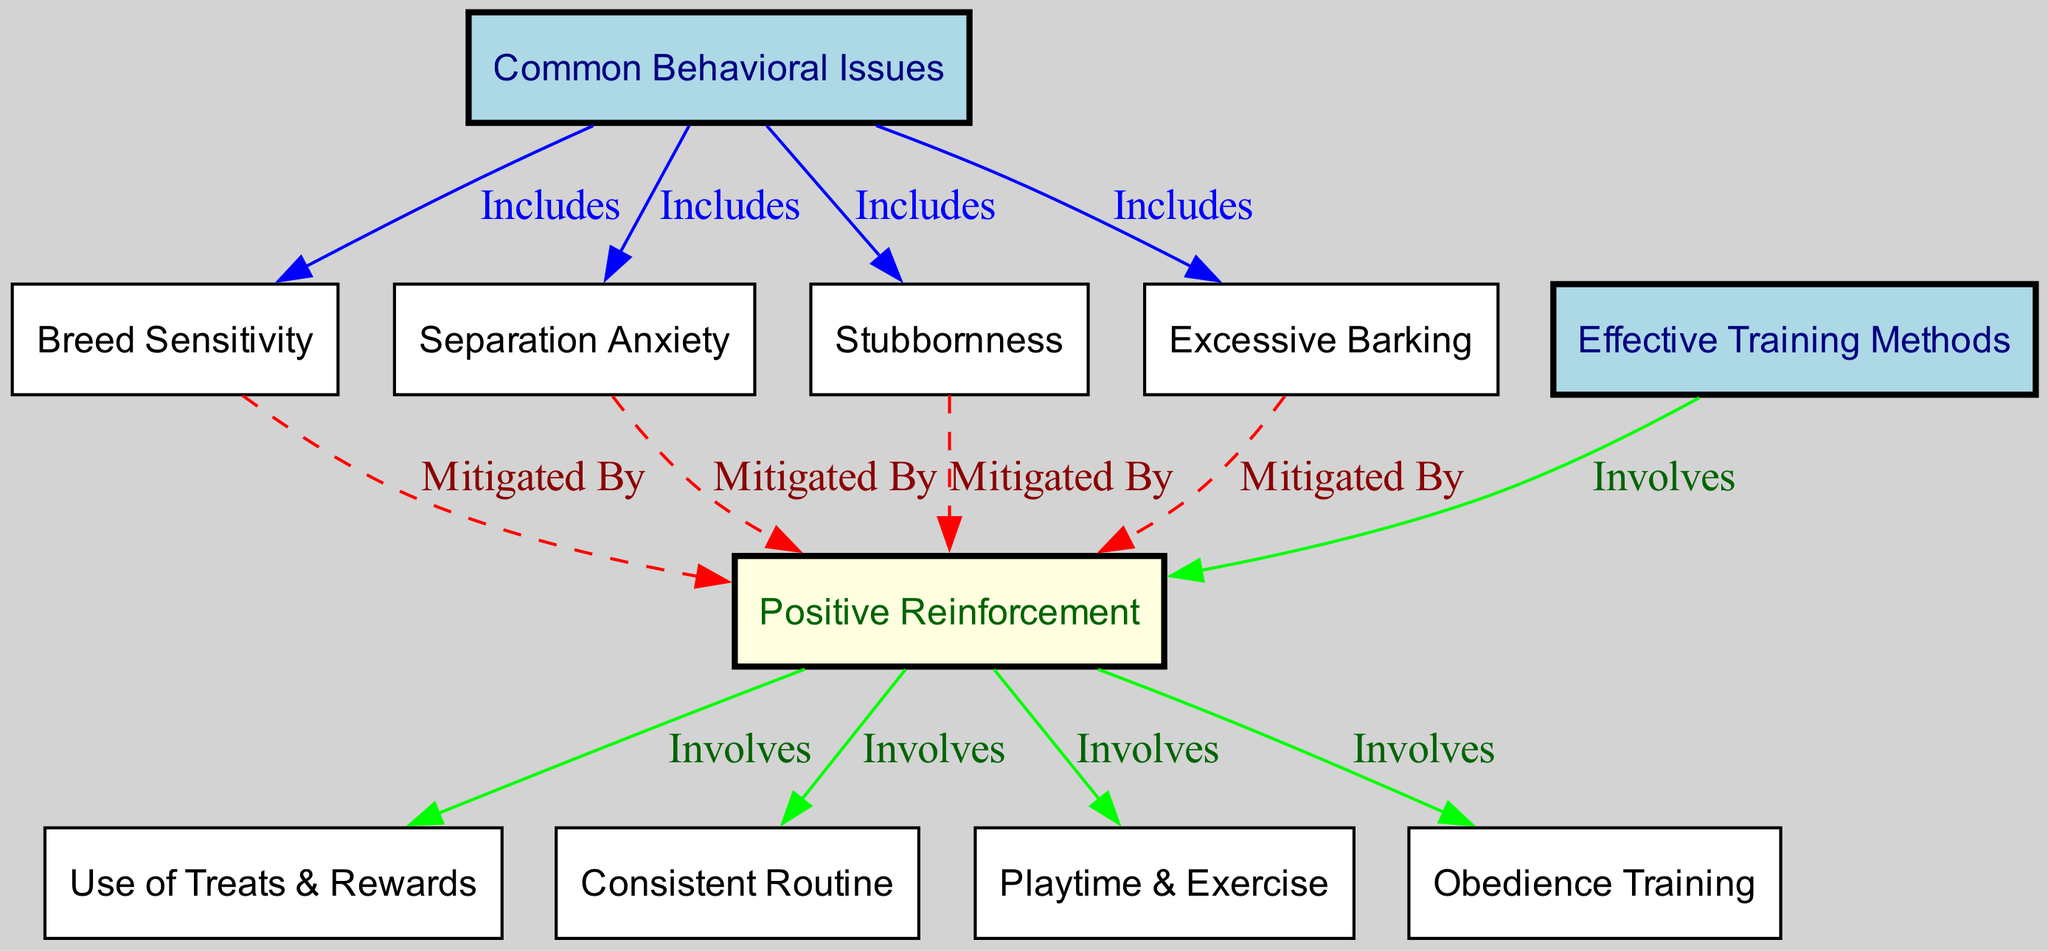What are some common behavioral issues in French dog breeds? The diagram lists the behavioral issues under the "Common Behavioral Issues" node, which includes "Separation Anxiety," "Stubbornness," "Excessive Barking," and "Breed Sensitivity."
Answer: Separation Anxiety, Stubbornness, Excessive Barking, Breed Sensitivity How many training methods are mentioned in the diagram? Counting the nodes under "Effective Training Methods," the diagram includes four training methods: "Use of Treats & Rewards," "Consistent Routine," "Playtime & Exercise," and "Obedience Training."
Answer: 4 Which behavioral issue is mitigated by positive reinforcement? The diagram shows arrows from each behavioral issue (Separation Anxiety, Stubbornness, Excessive Barking, Breed Sensitivity) to the "Positive Reinforcement" node. This indicates that all these issues can be addressed with positive reinforcement.
Answer: Separation Anxiety, Stubbornness, Excessive Barking, Breed Sensitivity What does the edge labeled 'Mitigated By' connect? The edge labeled "Mitigated By" connects various behavioral issues to the "Positive Reinforcement" node. This is a specific type of relationship showing that positive reinforcement helps reduce the severity of these issues.
Answer: Various behavioral issues What is a key component of positive reinforcement training methods? The diagram details that "Positive Reinforcement" specifically involves "Use of Treats & Rewards," "Consistent Routine," "Playtime & Exercise," and "Obedience Training," highlighting that these are essential elements in the approach.
Answer: Use of Treats & Rewards, Consistent Routine, Playtime & Exercise, Obedience Training How many total edges connect the behavioral issues to training methods? By analyzing the diagram, each behavioral issue connects to the "Positive Reinforcement" node through the special edge labeled "Mitigated By." Since there are four behavioral issues, there are four corresponding edges.
Answer: 4 Which behavioral issue might require the most specific training method? Given that "Stubbornness" can be particularly challenging, the training method of "Obedience Training" is likely vital for addressing this issue, making it a key approach in its mitigation through positive reinforcement.
Answer: Obedience Training What kind of relationship is shown between behavioral issues and training methods? The diagram displays two different types of relationships: "Includes," which lists behavioral issues under the main category, and "Mitigated By," which indicates how these issues are addressed by the training methods.
Answer: Includes, Mitigated By 